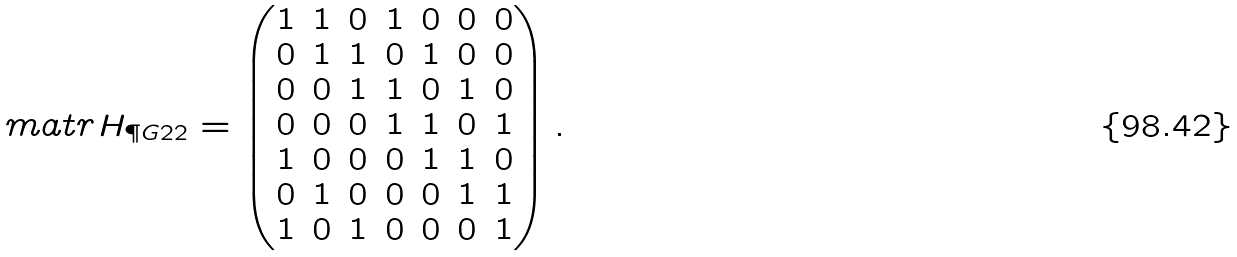Convert formula to latex. <formula><loc_0><loc_0><loc_500><loc_500>\ m a t r { H } _ { \P G { 2 } { 2 } } & = \begin{pmatrix} 1 & 1 & 0 & 1 & 0 & 0 & 0 \\ 0 & 1 & 1 & 0 & 1 & 0 & 0 \\ 0 & 0 & 1 & 1 & 0 & 1 & 0 \\ 0 & 0 & 0 & 1 & 1 & 0 & 1 \\ 1 & 0 & 0 & 0 & 1 & 1 & 0 \\ 0 & 1 & 0 & 0 & 0 & 1 & 1 \\ 1 & 0 & 1 & 0 & 0 & 0 & 1 \end{pmatrix} .</formula> 